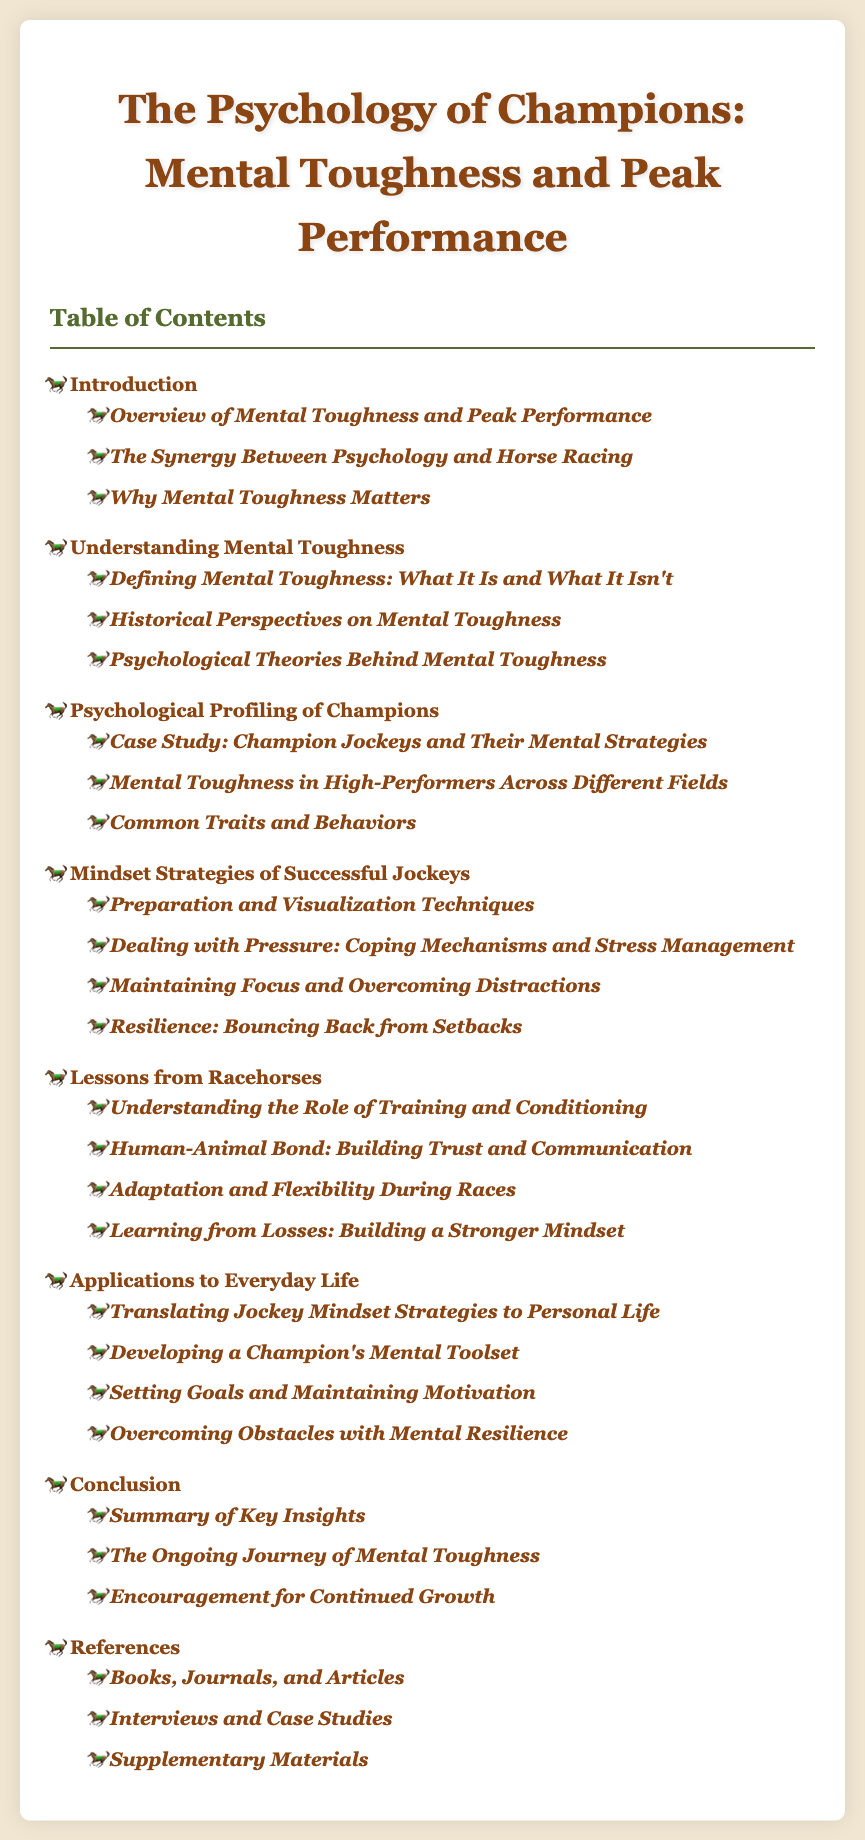what is the title of the document? The title is the main heading presented at the top of the document.
Answer: The Psychology of Champions: Mental Toughness and Peak Performance how many chapters are there in the table of contents? The total number of main chapters can be counted from the list in the table of contents.
Answer: 7 what is the first section under the "Introduction" chapter? The first section is listed as the first item in the sublist of the "Introduction" chapter.
Answer: Overview of Mental Toughness and Peak Performance name a coping mechanism mentioned for dealing with pressure. The section discusses various strategies for handling pressure among successful jockeys.
Answer: Coping Mechanisms and Stress Management what is the main focus of the "Lessons from Racehorses" chapter? This chapter focuses on insights derived from the experiences of racehorses that can be applied to mental toughness.
Answer: Training and Conditioning which chapter discusses the psychological profiling of champions? This can be identified by the specific chapter title that refers to the psychological analysis of successful individuals.
Answer: Psychological Profiling of Champions what is the last section in the "Conclusion" chapter? The last section can be identified as the final item in the sublist under the conclusion chapter.
Answer: Encouragement for Continued Growth 